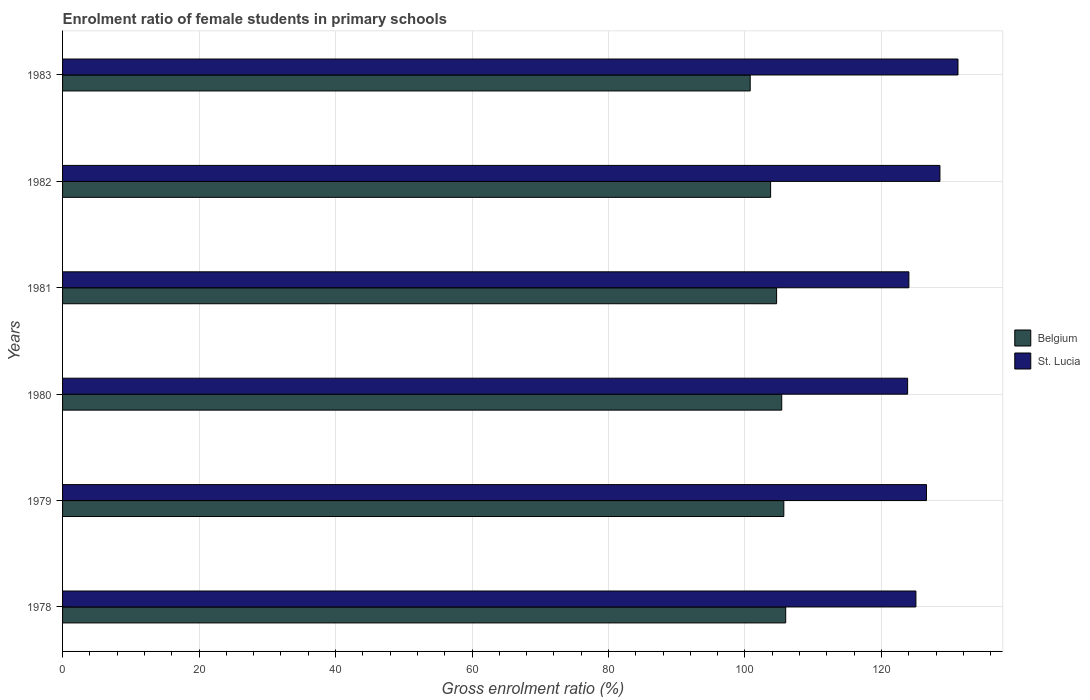How many bars are there on the 6th tick from the bottom?
Your answer should be very brief. 2. What is the label of the 1st group of bars from the top?
Your answer should be compact. 1983. In how many cases, is the number of bars for a given year not equal to the number of legend labels?
Offer a very short reply. 0. What is the enrolment ratio of female students in primary schools in St. Lucia in 1979?
Make the answer very short. 126.61. Across all years, what is the maximum enrolment ratio of female students in primary schools in Belgium?
Your answer should be very brief. 105.97. Across all years, what is the minimum enrolment ratio of female students in primary schools in St. Lucia?
Offer a very short reply. 123.84. What is the total enrolment ratio of female students in primary schools in Belgium in the graph?
Ensure brevity in your answer.  626.23. What is the difference between the enrolment ratio of female students in primary schools in St. Lucia in 1980 and that in 1982?
Provide a short and direct response. -4.74. What is the difference between the enrolment ratio of female students in primary schools in St. Lucia in 1980 and the enrolment ratio of female students in primary schools in Belgium in 1978?
Ensure brevity in your answer.  17.87. What is the average enrolment ratio of female students in primary schools in Belgium per year?
Your response must be concise. 104.37. In the year 1981, what is the difference between the enrolment ratio of female students in primary schools in Belgium and enrolment ratio of female students in primary schools in St. Lucia?
Offer a terse response. -19.39. In how many years, is the enrolment ratio of female students in primary schools in St. Lucia greater than 12 %?
Your response must be concise. 6. What is the ratio of the enrolment ratio of female students in primary schools in Belgium in 1981 to that in 1983?
Offer a very short reply. 1.04. Is the enrolment ratio of female students in primary schools in Belgium in 1978 less than that in 1983?
Keep it short and to the point. No. Is the difference between the enrolment ratio of female students in primary schools in Belgium in 1978 and 1982 greater than the difference between the enrolment ratio of female students in primary schools in St. Lucia in 1978 and 1982?
Your answer should be very brief. Yes. What is the difference between the highest and the second highest enrolment ratio of female students in primary schools in Belgium?
Make the answer very short. 0.28. What is the difference between the highest and the lowest enrolment ratio of female students in primary schools in Belgium?
Offer a very short reply. 5.2. In how many years, is the enrolment ratio of female students in primary schools in St. Lucia greater than the average enrolment ratio of female students in primary schools in St. Lucia taken over all years?
Give a very brief answer. 3. What does the 1st bar from the top in 1981 represents?
Offer a terse response. St. Lucia. What does the 2nd bar from the bottom in 1979 represents?
Ensure brevity in your answer.  St. Lucia. Are all the bars in the graph horizontal?
Provide a succinct answer. Yes. Are the values on the major ticks of X-axis written in scientific E-notation?
Give a very brief answer. No. Does the graph contain any zero values?
Offer a terse response. No. Does the graph contain grids?
Keep it short and to the point. Yes. How are the legend labels stacked?
Make the answer very short. Vertical. What is the title of the graph?
Your answer should be compact. Enrolment ratio of female students in primary schools. Does "Tuvalu" appear as one of the legend labels in the graph?
Provide a short and direct response. No. What is the Gross enrolment ratio (%) of Belgium in 1978?
Give a very brief answer. 105.97. What is the Gross enrolment ratio (%) in St. Lucia in 1978?
Offer a very short reply. 125.06. What is the Gross enrolment ratio (%) in Belgium in 1979?
Offer a very short reply. 105.7. What is the Gross enrolment ratio (%) of St. Lucia in 1979?
Ensure brevity in your answer.  126.61. What is the Gross enrolment ratio (%) in Belgium in 1980?
Keep it short and to the point. 105.39. What is the Gross enrolment ratio (%) of St. Lucia in 1980?
Offer a terse response. 123.84. What is the Gross enrolment ratio (%) in Belgium in 1981?
Your response must be concise. 104.64. What is the Gross enrolment ratio (%) in St. Lucia in 1981?
Give a very brief answer. 124.03. What is the Gross enrolment ratio (%) of Belgium in 1982?
Ensure brevity in your answer.  103.76. What is the Gross enrolment ratio (%) in St. Lucia in 1982?
Provide a succinct answer. 128.58. What is the Gross enrolment ratio (%) of Belgium in 1983?
Your response must be concise. 100.77. What is the Gross enrolment ratio (%) in St. Lucia in 1983?
Provide a short and direct response. 131.22. Across all years, what is the maximum Gross enrolment ratio (%) in Belgium?
Make the answer very short. 105.97. Across all years, what is the maximum Gross enrolment ratio (%) in St. Lucia?
Offer a terse response. 131.22. Across all years, what is the minimum Gross enrolment ratio (%) of Belgium?
Keep it short and to the point. 100.77. Across all years, what is the minimum Gross enrolment ratio (%) in St. Lucia?
Provide a succinct answer. 123.84. What is the total Gross enrolment ratio (%) in Belgium in the graph?
Your answer should be very brief. 626.23. What is the total Gross enrolment ratio (%) in St. Lucia in the graph?
Your answer should be compact. 759.32. What is the difference between the Gross enrolment ratio (%) in Belgium in 1978 and that in 1979?
Provide a succinct answer. 0.28. What is the difference between the Gross enrolment ratio (%) in St. Lucia in 1978 and that in 1979?
Provide a succinct answer. -1.55. What is the difference between the Gross enrolment ratio (%) of Belgium in 1978 and that in 1980?
Provide a succinct answer. 0.58. What is the difference between the Gross enrolment ratio (%) of St. Lucia in 1978 and that in 1980?
Provide a short and direct response. 1.22. What is the difference between the Gross enrolment ratio (%) of Belgium in 1978 and that in 1981?
Offer a terse response. 1.33. What is the difference between the Gross enrolment ratio (%) in St. Lucia in 1978 and that in 1981?
Ensure brevity in your answer.  1.03. What is the difference between the Gross enrolment ratio (%) in Belgium in 1978 and that in 1982?
Provide a succinct answer. 2.21. What is the difference between the Gross enrolment ratio (%) in St. Lucia in 1978 and that in 1982?
Your answer should be compact. -3.52. What is the difference between the Gross enrolment ratio (%) of Belgium in 1978 and that in 1983?
Your response must be concise. 5.2. What is the difference between the Gross enrolment ratio (%) of St. Lucia in 1978 and that in 1983?
Ensure brevity in your answer.  -6.16. What is the difference between the Gross enrolment ratio (%) of Belgium in 1979 and that in 1980?
Your answer should be very brief. 0.31. What is the difference between the Gross enrolment ratio (%) of St. Lucia in 1979 and that in 1980?
Make the answer very short. 2.77. What is the difference between the Gross enrolment ratio (%) of Belgium in 1979 and that in 1981?
Make the answer very short. 1.06. What is the difference between the Gross enrolment ratio (%) of St. Lucia in 1979 and that in 1981?
Offer a very short reply. 2.58. What is the difference between the Gross enrolment ratio (%) of Belgium in 1979 and that in 1982?
Keep it short and to the point. 1.94. What is the difference between the Gross enrolment ratio (%) in St. Lucia in 1979 and that in 1982?
Your answer should be compact. -1.97. What is the difference between the Gross enrolment ratio (%) of Belgium in 1979 and that in 1983?
Give a very brief answer. 4.93. What is the difference between the Gross enrolment ratio (%) of St. Lucia in 1979 and that in 1983?
Your answer should be compact. -4.61. What is the difference between the Gross enrolment ratio (%) in Belgium in 1980 and that in 1981?
Your answer should be very brief. 0.75. What is the difference between the Gross enrolment ratio (%) of St. Lucia in 1980 and that in 1981?
Make the answer very short. -0.19. What is the difference between the Gross enrolment ratio (%) of Belgium in 1980 and that in 1982?
Provide a short and direct response. 1.63. What is the difference between the Gross enrolment ratio (%) in St. Lucia in 1980 and that in 1982?
Provide a short and direct response. -4.74. What is the difference between the Gross enrolment ratio (%) in Belgium in 1980 and that in 1983?
Your answer should be compact. 4.62. What is the difference between the Gross enrolment ratio (%) in St. Lucia in 1980 and that in 1983?
Ensure brevity in your answer.  -7.38. What is the difference between the Gross enrolment ratio (%) in Belgium in 1981 and that in 1982?
Your answer should be very brief. 0.88. What is the difference between the Gross enrolment ratio (%) in St. Lucia in 1981 and that in 1982?
Your answer should be compact. -4.55. What is the difference between the Gross enrolment ratio (%) in Belgium in 1981 and that in 1983?
Ensure brevity in your answer.  3.87. What is the difference between the Gross enrolment ratio (%) in St. Lucia in 1981 and that in 1983?
Keep it short and to the point. -7.19. What is the difference between the Gross enrolment ratio (%) of Belgium in 1982 and that in 1983?
Your answer should be very brief. 2.99. What is the difference between the Gross enrolment ratio (%) of St. Lucia in 1982 and that in 1983?
Your answer should be compact. -2.64. What is the difference between the Gross enrolment ratio (%) of Belgium in 1978 and the Gross enrolment ratio (%) of St. Lucia in 1979?
Give a very brief answer. -20.63. What is the difference between the Gross enrolment ratio (%) in Belgium in 1978 and the Gross enrolment ratio (%) in St. Lucia in 1980?
Provide a short and direct response. -17.87. What is the difference between the Gross enrolment ratio (%) in Belgium in 1978 and the Gross enrolment ratio (%) in St. Lucia in 1981?
Your answer should be compact. -18.05. What is the difference between the Gross enrolment ratio (%) in Belgium in 1978 and the Gross enrolment ratio (%) in St. Lucia in 1982?
Your answer should be very brief. -22.6. What is the difference between the Gross enrolment ratio (%) in Belgium in 1978 and the Gross enrolment ratio (%) in St. Lucia in 1983?
Provide a short and direct response. -25.25. What is the difference between the Gross enrolment ratio (%) of Belgium in 1979 and the Gross enrolment ratio (%) of St. Lucia in 1980?
Keep it short and to the point. -18.14. What is the difference between the Gross enrolment ratio (%) of Belgium in 1979 and the Gross enrolment ratio (%) of St. Lucia in 1981?
Ensure brevity in your answer.  -18.33. What is the difference between the Gross enrolment ratio (%) in Belgium in 1979 and the Gross enrolment ratio (%) in St. Lucia in 1982?
Give a very brief answer. -22.88. What is the difference between the Gross enrolment ratio (%) of Belgium in 1979 and the Gross enrolment ratio (%) of St. Lucia in 1983?
Provide a short and direct response. -25.52. What is the difference between the Gross enrolment ratio (%) in Belgium in 1980 and the Gross enrolment ratio (%) in St. Lucia in 1981?
Offer a terse response. -18.63. What is the difference between the Gross enrolment ratio (%) of Belgium in 1980 and the Gross enrolment ratio (%) of St. Lucia in 1982?
Provide a succinct answer. -23.19. What is the difference between the Gross enrolment ratio (%) in Belgium in 1980 and the Gross enrolment ratio (%) in St. Lucia in 1983?
Make the answer very short. -25.83. What is the difference between the Gross enrolment ratio (%) of Belgium in 1981 and the Gross enrolment ratio (%) of St. Lucia in 1982?
Provide a succinct answer. -23.94. What is the difference between the Gross enrolment ratio (%) of Belgium in 1981 and the Gross enrolment ratio (%) of St. Lucia in 1983?
Make the answer very short. -26.58. What is the difference between the Gross enrolment ratio (%) of Belgium in 1982 and the Gross enrolment ratio (%) of St. Lucia in 1983?
Provide a succinct answer. -27.46. What is the average Gross enrolment ratio (%) in Belgium per year?
Your response must be concise. 104.37. What is the average Gross enrolment ratio (%) in St. Lucia per year?
Make the answer very short. 126.55. In the year 1978, what is the difference between the Gross enrolment ratio (%) of Belgium and Gross enrolment ratio (%) of St. Lucia?
Your response must be concise. -19.08. In the year 1979, what is the difference between the Gross enrolment ratio (%) in Belgium and Gross enrolment ratio (%) in St. Lucia?
Offer a terse response. -20.91. In the year 1980, what is the difference between the Gross enrolment ratio (%) of Belgium and Gross enrolment ratio (%) of St. Lucia?
Provide a succinct answer. -18.45. In the year 1981, what is the difference between the Gross enrolment ratio (%) of Belgium and Gross enrolment ratio (%) of St. Lucia?
Make the answer very short. -19.39. In the year 1982, what is the difference between the Gross enrolment ratio (%) in Belgium and Gross enrolment ratio (%) in St. Lucia?
Your answer should be compact. -24.81. In the year 1983, what is the difference between the Gross enrolment ratio (%) in Belgium and Gross enrolment ratio (%) in St. Lucia?
Offer a very short reply. -30.45. What is the ratio of the Gross enrolment ratio (%) in St. Lucia in 1978 to that in 1979?
Your answer should be very brief. 0.99. What is the ratio of the Gross enrolment ratio (%) of Belgium in 1978 to that in 1980?
Make the answer very short. 1.01. What is the ratio of the Gross enrolment ratio (%) of St. Lucia in 1978 to that in 1980?
Keep it short and to the point. 1.01. What is the ratio of the Gross enrolment ratio (%) of Belgium in 1978 to that in 1981?
Provide a succinct answer. 1.01. What is the ratio of the Gross enrolment ratio (%) in St. Lucia in 1978 to that in 1981?
Ensure brevity in your answer.  1.01. What is the ratio of the Gross enrolment ratio (%) of Belgium in 1978 to that in 1982?
Offer a terse response. 1.02. What is the ratio of the Gross enrolment ratio (%) in St. Lucia in 1978 to that in 1982?
Your answer should be very brief. 0.97. What is the ratio of the Gross enrolment ratio (%) of Belgium in 1978 to that in 1983?
Offer a very short reply. 1.05. What is the ratio of the Gross enrolment ratio (%) in St. Lucia in 1978 to that in 1983?
Keep it short and to the point. 0.95. What is the ratio of the Gross enrolment ratio (%) in Belgium in 1979 to that in 1980?
Offer a very short reply. 1. What is the ratio of the Gross enrolment ratio (%) of St. Lucia in 1979 to that in 1980?
Make the answer very short. 1.02. What is the ratio of the Gross enrolment ratio (%) of St. Lucia in 1979 to that in 1981?
Ensure brevity in your answer.  1.02. What is the ratio of the Gross enrolment ratio (%) of Belgium in 1979 to that in 1982?
Give a very brief answer. 1.02. What is the ratio of the Gross enrolment ratio (%) of St. Lucia in 1979 to that in 1982?
Make the answer very short. 0.98. What is the ratio of the Gross enrolment ratio (%) of Belgium in 1979 to that in 1983?
Provide a short and direct response. 1.05. What is the ratio of the Gross enrolment ratio (%) in St. Lucia in 1979 to that in 1983?
Offer a terse response. 0.96. What is the ratio of the Gross enrolment ratio (%) of Belgium in 1980 to that in 1982?
Keep it short and to the point. 1.02. What is the ratio of the Gross enrolment ratio (%) of St. Lucia in 1980 to that in 1982?
Offer a very short reply. 0.96. What is the ratio of the Gross enrolment ratio (%) of Belgium in 1980 to that in 1983?
Your answer should be very brief. 1.05. What is the ratio of the Gross enrolment ratio (%) in St. Lucia in 1980 to that in 1983?
Ensure brevity in your answer.  0.94. What is the ratio of the Gross enrolment ratio (%) in Belgium in 1981 to that in 1982?
Your answer should be very brief. 1.01. What is the ratio of the Gross enrolment ratio (%) of St. Lucia in 1981 to that in 1982?
Give a very brief answer. 0.96. What is the ratio of the Gross enrolment ratio (%) in Belgium in 1981 to that in 1983?
Ensure brevity in your answer.  1.04. What is the ratio of the Gross enrolment ratio (%) of St. Lucia in 1981 to that in 1983?
Your answer should be compact. 0.95. What is the ratio of the Gross enrolment ratio (%) of Belgium in 1982 to that in 1983?
Make the answer very short. 1.03. What is the ratio of the Gross enrolment ratio (%) of St. Lucia in 1982 to that in 1983?
Offer a very short reply. 0.98. What is the difference between the highest and the second highest Gross enrolment ratio (%) in Belgium?
Ensure brevity in your answer.  0.28. What is the difference between the highest and the second highest Gross enrolment ratio (%) in St. Lucia?
Your answer should be very brief. 2.64. What is the difference between the highest and the lowest Gross enrolment ratio (%) of Belgium?
Ensure brevity in your answer.  5.2. What is the difference between the highest and the lowest Gross enrolment ratio (%) of St. Lucia?
Keep it short and to the point. 7.38. 